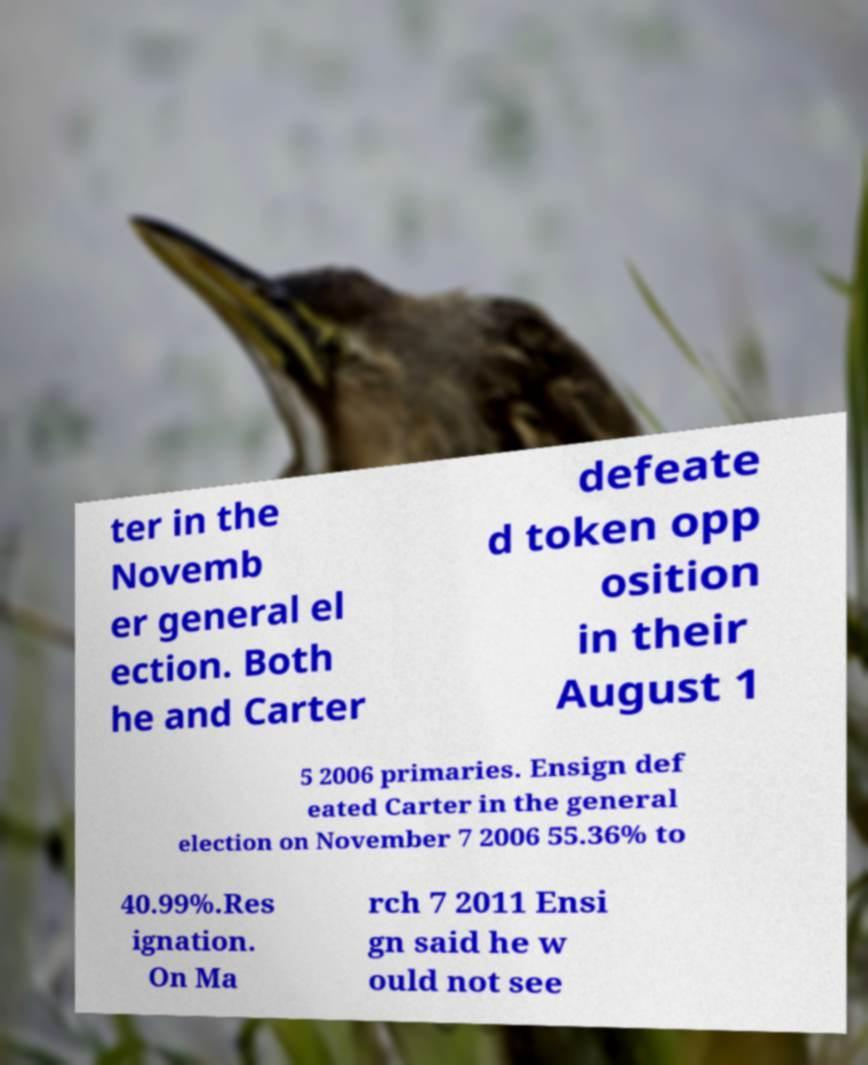Can you read and provide the text displayed in the image?This photo seems to have some interesting text. Can you extract and type it out for me? ter in the Novemb er general el ection. Both he and Carter defeate d token opp osition in their August 1 5 2006 primaries. Ensign def eated Carter in the general election on November 7 2006 55.36% to 40.99%.Res ignation. On Ma rch 7 2011 Ensi gn said he w ould not see 